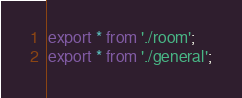Convert code to text. <code><loc_0><loc_0><loc_500><loc_500><_TypeScript_>export * from './room';
export * from './general';
</code> 